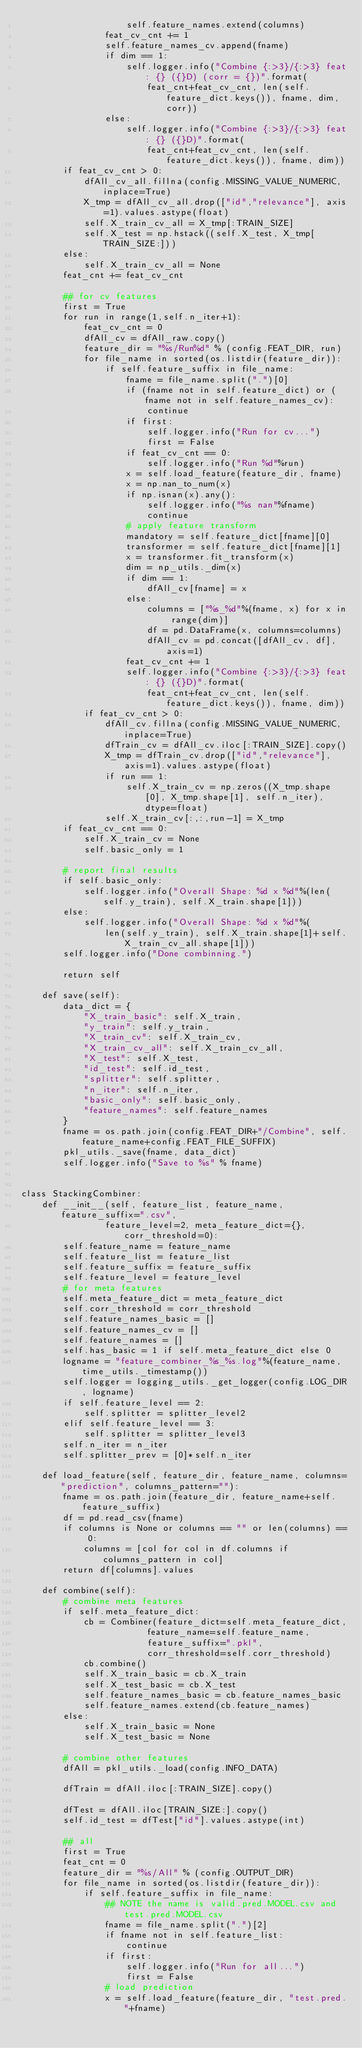<code> <loc_0><loc_0><loc_500><loc_500><_Python_>                    self.feature_names.extend(columns)
                feat_cv_cnt += 1
                self.feature_names_cv.append(fname)
                if dim == 1:
                    self.logger.info("Combine {:>3}/{:>3} feat: {} ({}D) (corr = {})".format(
                        feat_cnt+feat_cv_cnt, len(self.feature_dict.keys()), fname, dim, corr))
                else:
                    self.logger.info("Combine {:>3}/{:>3} feat: {} ({}D)".format(
                        feat_cnt+feat_cv_cnt, len(self.feature_dict.keys()), fname, dim))
        if feat_cv_cnt > 0:
            dfAll_cv_all.fillna(config.MISSING_VALUE_NUMERIC, inplace=True)
            X_tmp = dfAll_cv_all.drop(["id","relevance"], axis=1).values.astype(float)
            self.X_train_cv_all = X_tmp[:TRAIN_SIZE]
            self.X_test = np.hstack((self.X_test, X_tmp[TRAIN_SIZE:]))
        else:
            self.X_train_cv_all = None
        feat_cnt += feat_cv_cnt

        ## for cv features
        first = True
        for run in range(1,self.n_iter+1):
            feat_cv_cnt = 0
            dfAll_cv = dfAll_raw.copy()
            feature_dir = "%s/Run%d" % (config.FEAT_DIR, run)
            for file_name in sorted(os.listdir(feature_dir)):
                if self.feature_suffix in file_name:
                    fname = file_name.split(".")[0]
                    if (fname not in self.feature_dict) or (fname not in self.feature_names_cv):
                        continue
                    if first:
                        self.logger.info("Run for cv...")
                        first = False
                    if feat_cv_cnt == 0:
                        self.logger.info("Run %d"%run)
                    x = self.load_feature(feature_dir, fname)
                    x = np.nan_to_num(x)
                    if np.isnan(x).any():
                        self.logger.info("%s nan"%fname)
                        continue
                    # apply feature transform
                    mandatory = self.feature_dict[fname][0]
                    transformer = self.feature_dict[fname][1]
                    x = transformer.fit_transform(x)
                    dim = np_utils._dim(x)
                    if dim == 1:
                        dfAll_cv[fname] = x
                    else:
                        columns = ["%s_%d"%(fname, x) for x in range(dim)]
                        df = pd.DataFrame(x, columns=columns)
                        dfAll_cv = pd.concat([dfAll_cv, df], axis=1)
                    feat_cv_cnt += 1
                    self.logger.info("Combine {:>3}/{:>3} feat: {} ({}D)".format(
                        feat_cnt+feat_cv_cnt, len(self.feature_dict.keys()), fname, dim))
            if feat_cv_cnt > 0:
                dfAll_cv.fillna(config.MISSING_VALUE_NUMERIC, inplace=True)
                dfTrain_cv = dfAll_cv.iloc[:TRAIN_SIZE].copy()
                X_tmp = dfTrain_cv.drop(["id","relevance"], axis=1).values.astype(float)
                if run == 1:
                    self.X_train_cv = np.zeros((X_tmp.shape[0], X_tmp.shape[1], self.n_iter), dtype=float)
                self.X_train_cv[:,:,run-1] = X_tmp
        if feat_cv_cnt == 0:
            self.X_train_cv = None
            self.basic_only = 1

        # report final results
        if self.basic_only:
            self.logger.info("Overall Shape: %d x %d"%(len(self.y_train), self.X_train.shape[1]))
        else:
            self.logger.info("Overall Shape: %d x %d"%(
                len(self.y_train), self.X_train.shape[1]+self.X_train_cv_all.shape[1])) 
        self.logger.info("Done combinning.")

        return self

    def save(self):
        data_dict = {
            "X_train_basic": self.X_train,
            "y_train": self.y_train,
            "X_train_cv": self.X_train_cv,
            "X_train_cv_all": self.X_train_cv_all,
            "X_test": self.X_test,                    
            "id_test": self.id_test,
            "splitter": self.splitter,
            "n_iter": self.n_iter,
            "basic_only": self.basic_only,
            "feature_names": self.feature_names
        }
        fname = os.path.join(config.FEAT_DIR+"/Combine", self.feature_name+config.FEAT_FILE_SUFFIX)
        pkl_utils._save(fname, data_dict)
        self.logger.info("Save to %s" % fname)


class StackingCombiner:
    def __init__(self, feature_list, feature_name, feature_suffix=".csv",
                feature_level=2, meta_feature_dict={}, corr_threshold=0):
        self.feature_name = feature_name
        self.feature_list = feature_list
        self.feature_suffix = feature_suffix
        self.feature_level = feature_level
        # for meta features
        self.meta_feature_dict = meta_feature_dict
        self.corr_threshold = corr_threshold
        self.feature_names_basic = []
        self.feature_names_cv = []
        self.feature_names = []
        self.has_basic = 1 if self.meta_feature_dict else 0
        logname = "feature_combiner_%s_%s.log"%(feature_name, time_utils._timestamp())
        self.logger = logging_utils._get_logger(config.LOG_DIR, logname)
        if self.feature_level == 2:
            self.splitter = splitter_level2
        elif self.feature_level == 3:
            self.splitter = splitter_level3
        self.n_iter = n_iter
        self.splitter_prev = [0]*self.n_iter

    def load_feature(self, feature_dir, feature_name, columns="prediction", columns_pattern=""):
        fname = os.path.join(feature_dir, feature_name+self.feature_suffix)
        df = pd.read_csv(fname)
        if columns is None or columns == "" or len(columns) == 0:
            columns = [col for col in df.columns if columns_pattern in col]
        return df[columns].values

    def combine(self):
        # combine meta features
        if self.meta_feature_dict:
            cb = Combiner(feature_dict=self.meta_feature_dict, 
                        feature_name=self.feature_name, 
                        feature_suffix=".pkl", 
                        corr_threshold=self.corr_threshold)
            cb.combine()
            self.X_train_basic = cb.X_train
            self.X_test_basic = cb.X_test
            self.feature_names_basic = cb.feature_names_basic
            self.feature_names.extend(cb.feature_names)
        else:
            self.X_train_basic = None
            self.X_test_basic = None

        # combine other features
        dfAll = pkl_utils._load(config.INFO_DATA)

        dfTrain = dfAll.iloc[:TRAIN_SIZE].copy()

        dfTest = dfAll.iloc[TRAIN_SIZE:].copy()
        self.id_test = dfTest["id"].values.astype(int)

        ## all
        first = True
        feat_cnt = 0
        feature_dir = "%s/All" % (config.OUTPUT_DIR)
        for file_name in sorted(os.listdir(feature_dir)):
            if self.feature_suffix in file_name:
                ## NOTE the name is valid.pred.MODEL.csv and test.pred.MODEL.csv
                fname = file_name.split(".")[2]
                if fname not in self.feature_list:
                    continue
                if first:
                    self.logger.info("Run for all...")
                    first = False
                # load prediction
                x = self.load_feature(feature_dir, "test.pred."+fname)</code> 